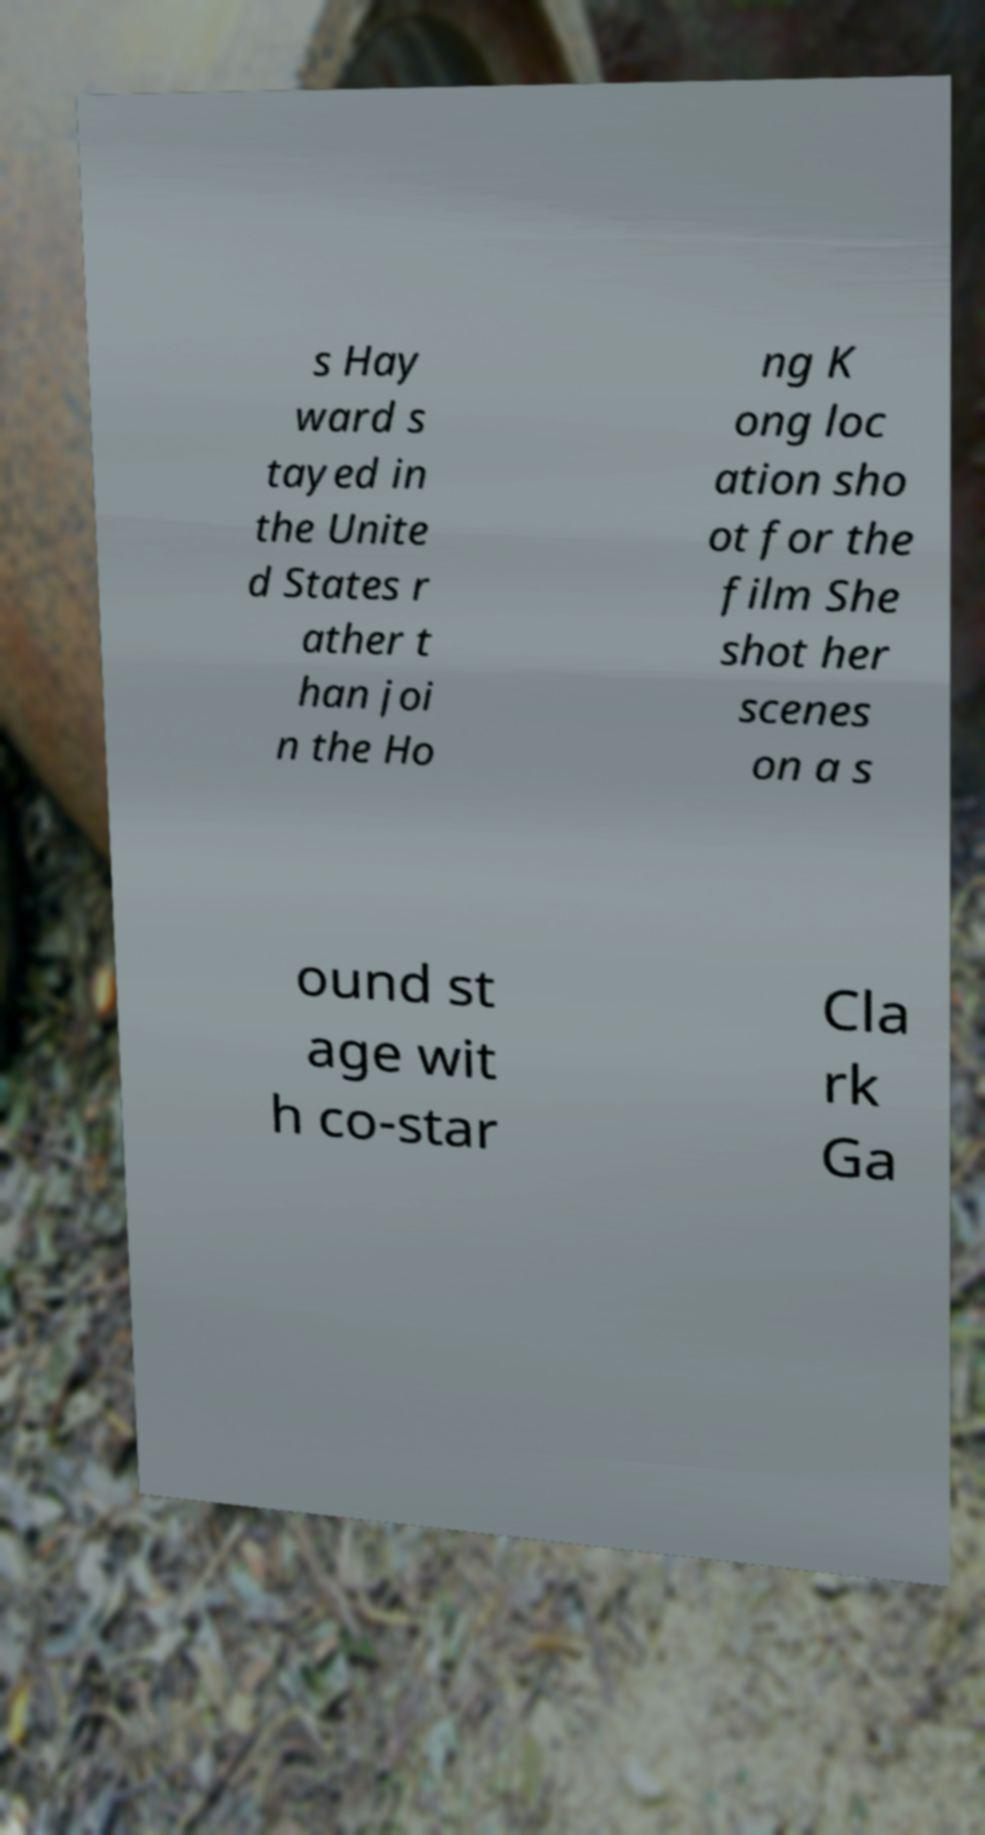Please identify and transcribe the text found in this image. s Hay ward s tayed in the Unite d States r ather t han joi n the Ho ng K ong loc ation sho ot for the film She shot her scenes on a s ound st age wit h co-star Cla rk Ga 